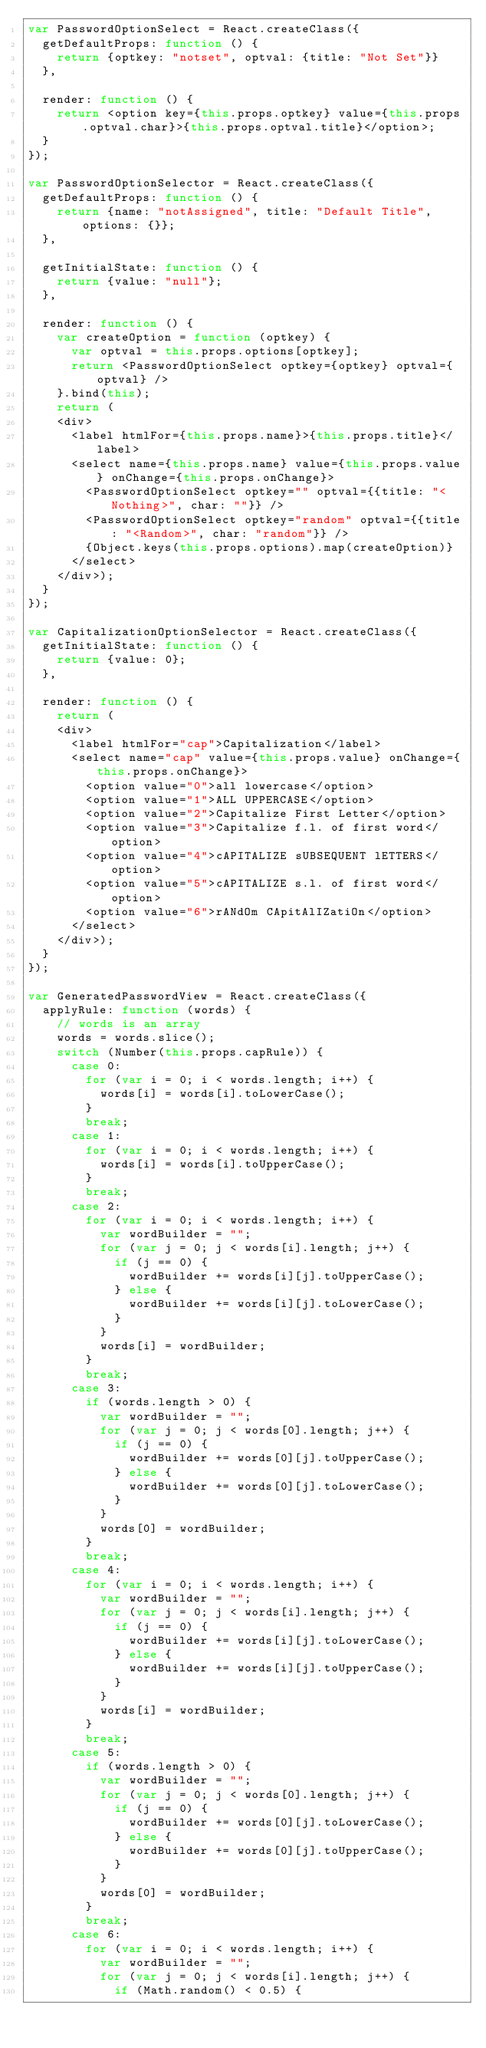<code> <loc_0><loc_0><loc_500><loc_500><_JavaScript_>var PasswordOptionSelect = React.createClass({
	getDefaultProps: function () {
		return {optkey: "notset", optval: {title: "Not Set"}}
	},

	render: function () {
		return <option key={this.props.optkey} value={this.props.optval.char}>{this.props.optval.title}</option>;
	}
});

var PasswordOptionSelector = React.createClass({
	getDefaultProps: function () {
		return {name: "notAssigned", title: "Default Title", options: {}};
	},

	getInitialState: function () {
		return {value: "null"};
	},

	render: function () {
		var createOption = function (optkey) {
			var optval = this.props.options[optkey];
			return <PasswordOptionSelect optkey={optkey} optval={optval} />
		}.bind(this);
		return (
		<div>
			<label htmlFor={this.props.name}>{this.props.title}</label>
			<select name={this.props.name} value={this.props.value} onChange={this.props.onChange}>
				<PasswordOptionSelect optkey="" optval={{title: "<Nothing>", char: ""}} />
				<PasswordOptionSelect optkey="random" optval={{title: "<Random>", char: "random"}} />
				{Object.keys(this.props.options).map(createOption)}
			</select>
		</div>);
	}
});

var CapitalizationOptionSelector = React.createClass({
	getInitialState: function () {
		return {value: 0};
	},

	render: function () {
		return (
		<div>
			<label htmlFor="cap">Capitalization</label>
			<select name="cap" value={this.props.value} onChange={this.props.onChange}>
				<option value="0">all lowercase</option>
				<option value="1">ALL UPPERCASE</option>
				<option value="2">Capitalize First Letter</option>
				<option value="3">Capitalize f.l. of first word</option>
				<option value="4">cAPITALIZE sUBSEQUENT lETTERS</option>
				<option value="5">cAPITALIZE s.l. of first word</option>
				<option value="6">rANdOm CApitAlIZatiOn</option>
			</select>
		</div>);
	}
});

var GeneratedPasswordView = React.createClass({
	applyRule: function (words) {
		// words is an array
		words = words.slice();
		switch (Number(this.props.capRule)) {
			case 0:
				for (var i = 0; i < words.length; i++) {
					words[i] = words[i].toLowerCase();
				}
				break;
			case 1:
				for (var i = 0; i < words.length; i++) {
					words[i] = words[i].toUpperCase();
				}
				break;
			case 2:
				for (var i = 0; i < words.length; i++) {
					var wordBuilder = "";
					for (var j = 0; j < words[i].length; j++) {
						if (j == 0) {
							wordBuilder += words[i][j].toUpperCase();
						} else {
							wordBuilder += words[i][j].toLowerCase();
						}
					}
					words[i] = wordBuilder;
				}
				break;
			case 3:
				if (words.length > 0) {
					var wordBuilder = "";
					for (var j = 0; j < words[0].length; j++) {
						if (j == 0) {
							wordBuilder += words[0][j].toUpperCase();
						} else {
							wordBuilder += words[0][j].toLowerCase();
						}
					}
					words[0] = wordBuilder;
				}
				break;
			case 4:
				for (var i = 0; i < words.length; i++) {
					var wordBuilder = "";
					for (var j = 0; j < words[i].length; j++) {
						if (j == 0) {
							wordBuilder += words[i][j].toLowerCase();
						} else {
							wordBuilder += words[i][j].toUpperCase();
						}
					}
					words[i] = wordBuilder;
				}
				break;
			case 5:
				if (words.length > 0) {
					var wordBuilder = "";
					for (var j = 0; j < words[0].length; j++) {
						if (j == 0) {
							wordBuilder += words[0][j].toLowerCase();
						} else {
							wordBuilder += words[0][j].toUpperCase();
						}
					}
					words[0] = wordBuilder;
				}
				break;
			case 6:
				for (var i = 0; i < words.length; i++) {
					var wordBuilder = "";
					for (var j = 0; j < words[i].length; j++) {
						if (Math.random() < 0.5) {</code> 